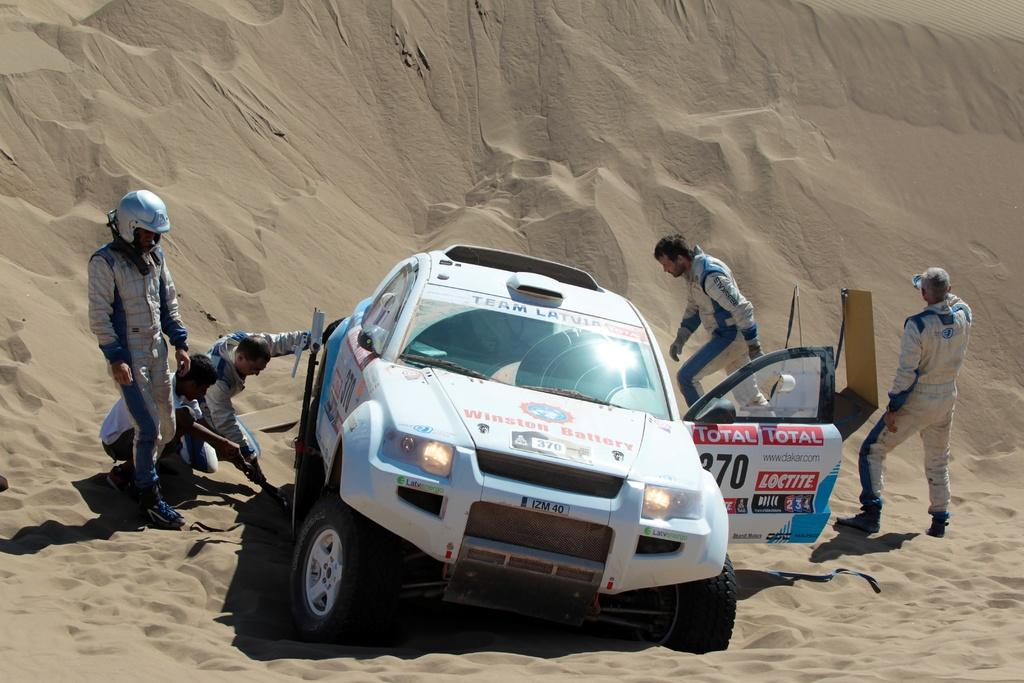What is the main subject in the center of the image? There is a car in the center of the image. What can be seen in the background of the image? There are people and sand visible in the background of the image. Where is the basketball court located in the image? There is no basketball court present in the image. 